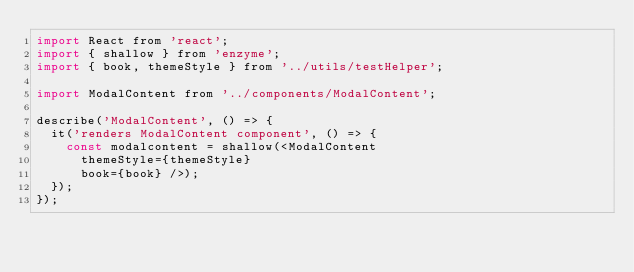<code> <loc_0><loc_0><loc_500><loc_500><_JavaScript_>import React from 'react';
import { shallow } from 'enzyme';
import { book, themeStyle } from '../utils/testHelper';

import ModalContent from '../components/ModalContent';

describe('ModalContent', () => {
  it('renders ModalContent component', () => {
    const modalcontent = shallow(<ModalContent
      themeStyle={themeStyle}
      book={book} />);
  });
});</code> 